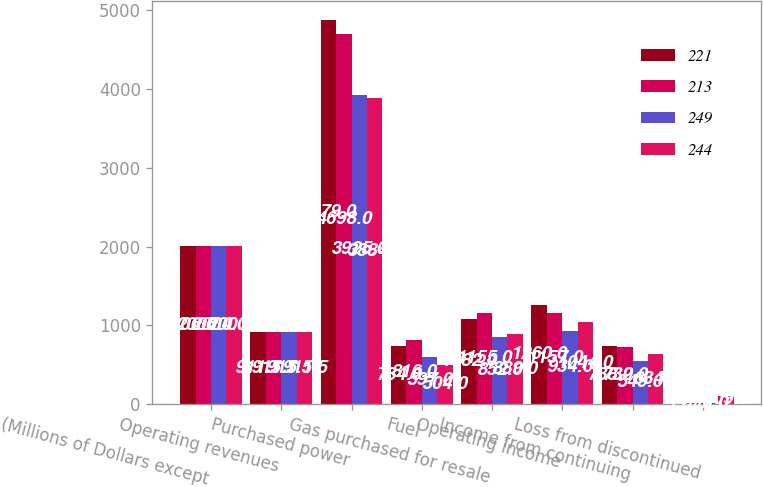<chart> <loc_0><loc_0><loc_500><loc_500><stacked_bar_chart><ecel><fcel>(Millions of Dollars except<fcel>Operating revenues<fcel>Purchased power<fcel>Fuel<fcel>Gas purchased for resale<fcel>Operating income<fcel>Income from continuing<fcel>Loss from discontinued<nl><fcel>221<fcel>2006<fcel>911.5<fcel>4879<fcel>734<fcel>1082<fcel>1260<fcel>738<fcel>1<nl><fcel>213<fcel>2005<fcel>911.5<fcel>4698<fcel>816<fcel>1155<fcel>1157<fcel>732<fcel>13<nl><fcel>249<fcel>2004<fcel>911.5<fcel>3925<fcel>597<fcel>852<fcel>934<fcel>549<fcel>12<nl><fcel>244<fcel>2003<fcel>911.5<fcel>3884<fcel>504<fcel>889<fcel>1044<fcel>634<fcel>109<nl></chart> 